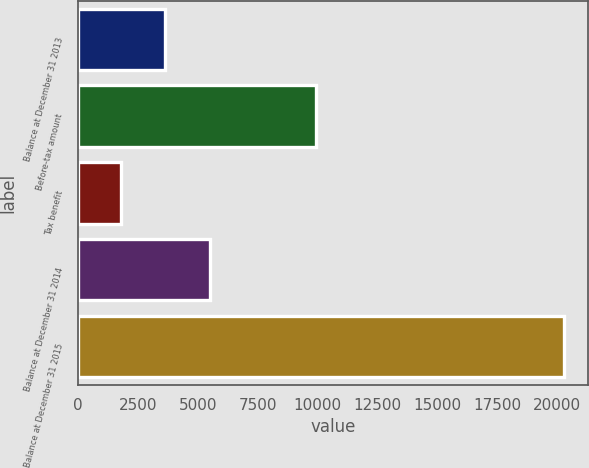<chart> <loc_0><loc_0><loc_500><loc_500><bar_chart><fcel>Balance at December 31 2013<fcel>Before-tax amount<fcel>Tax benefit<fcel>Balance at December 31 2014<fcel>Balance at December 31 2015<nl><fcel>3640.1<fcel>9934<fcel>1792<fcel>5513<fcel>20273<nl></chart> 